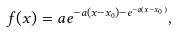Convert formula to latex. <formula><loc_0><loc_0><loc_500><loc_500>f ( x ) = a e ^ { - a ( x - x _ { 0 } ) - e ^ { - a ( x - x _ { 0 } ) } } ,</formula> 